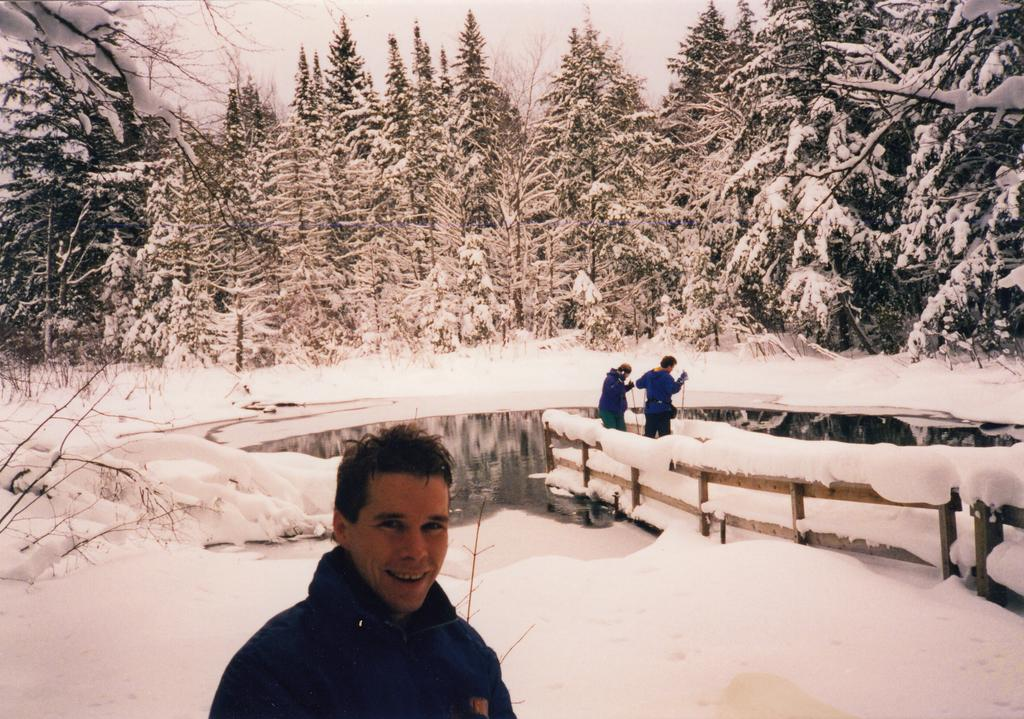Who is the main subject in the foreground of the image? There is a man in the foreground of the image. What can be seen in the background of the image? There are two people at the dock in the background of the image. What type of water body is visible in the image? There is a pond visible in the image. What is the weather condition in the image? There is snow in the image. What type of vegetation is present in the image? There are trees in the image. What color is the scarf worn by the man in the image? There is no mention of a scarf being worn by the man in the image. 